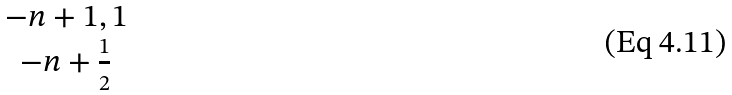<formula> <loc_0><loc_0><loc_500><loc_500>\begin{matrix} { - n + 1 , 1 } \\ { - n + { \frac { 1 } { 2 } } } \end{matrix}</formula> 